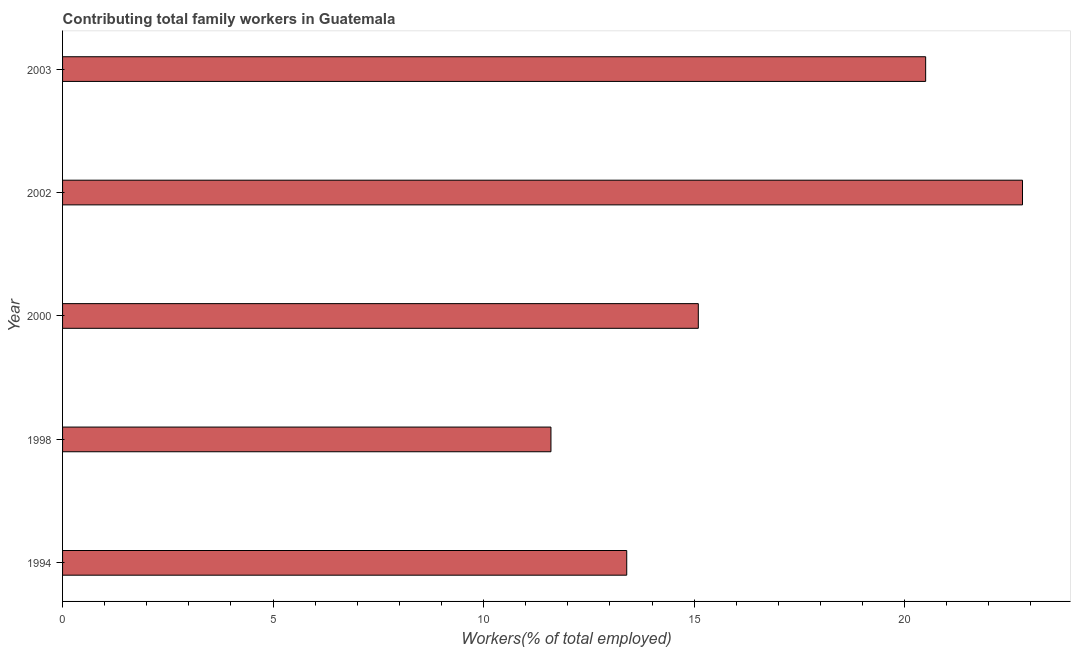Does the graph contain any zero values?
Make the answer very short. No. Does the graph contain grids?
Provide a short and direct response. No. What is the title of the graph?
Your response must be concise. Contributing total family workers in Guatemala. What is the label or title of the X-axis?
Provide a short and direct response. Workers(% of total employed). What is the contributing family workers in 2000?
Provide a succinct answer. 15.1. Across all years, what is the maximum contributing family workers?
Provide a short and direct response. 22.8. Across all years, what is the minimum contributing family workers?
Your response must be concise. 11.6. In which year was the contributing family workers maximum?
Make the answer very short. 2002. In which year was the contributing family workers minimum?
Give a very brief answer. 1998. What is the sum of the contributing family workers?
Make the answer very short. 83.4. What is the difference between the contributing family workers in 1994 and 2000?
Make the answer very short. -1.7. What is the average contributing family workers per year?
Keep it short and to the point. 16.68. What is the median contributing family workers?
Make the answer very short. 15.1. What is the ratio of the contributing family workers in 2000 to that in 2002?
Offer a very short reply. 0.66. Is the sum of the contributing family workers in 2002 and 2003 greater than the maximum contributing family workers across all years?
Give a very brief answer. Yes. What is the difference between the highest and the lowest contributing family workers?
Your response must be concise. 11.2. Are all the bars in the graph horizontal?
Provide a short and direct response. Yes. How many years are there in the graph?
Give a very brief answer. 5. Are the values on the major ticks of X-axis written in scientific E-notation?
Make the answer very short. No. What is the Workers(% of total employed) in 1994?
Provide a short and direct response. 13.4. What is the Workers(% of total employed) in 1998?
Keep it short and to the point. 11.6. What is the Workers(% of total employed) of 2000?
Your response must be concise. 15.1. What is the Workers(% of total employed) of 2002?
Provide a short and direct response. 22.8. What is the difference between the Workers(% of total employed) in 1994 and 1998?
Offer a very short reply. 1.8. What is the difference between the Workers(% of total employed) in 1994 and 2000?
Make the answer very short. -1.7. What is the difference between the Workers(% of total employed) in 1994 and 2002?
Provide a short and direct response. -9.4. What is the difference between the Workers(% of total employed) in 1994 and 2003?
Your answer should be compact. -7.1. What is the difference between the Workers(% of total employed) in 1998 and 2000?
Your response must be concise. -3.5. What is the difference between the Workers(% of total employed) in 1998 and 2002?
Your answer should be compact. -11.2. What is the difference between the Workers(% of total employed) in 2000 and 2002?
Your answer should be compact. -7.7. What is the difference between the Workers(% of total employed) in 2000 and 2003?
Your answer should be compact. -5.4. What is the ratio of the Workers(% of total employed) in 1994 to that in 1998?
Provide a short and direct response. 1.16. What is the ratio of the Workers(% of total employed) in 1994 to that in 2000?
Provide a succinct answer. 0.89. What is the ratio of the Workers(% of total employed) in 1994 to that in 2002?
Keep it short and to the point. 0.59. What is the ratio of the Workers(% of total employed) in 1994 to that in 2003?
Provide a short and direct response. 0.65. What is the ratio of the Workers(% of total employed) in 1998 to that in 2000?
Keep it short and to the point. 0.77. What is the ratio of the Workers(% of total employed) in 1998 to that in 2002?
Ensure brevity in your answer.  0.51. What is the ratio of the Workers(% of total employed) in 1998 to that in 2003?
Your answer should be compact. 0.57. What is the ratio of the Workers(% of total employed) in 2000 to that in 2002?
Keep it short and to the point. 0.66. What is the ratio of the Workers(% of total employed) in 2000 to that in 2003?
Your answer should be compact. 0.74. What is the ratio of the Workers(% of total employed) in 2002 to that in 2003?
Ensure brevity in your answer.  1.11. 